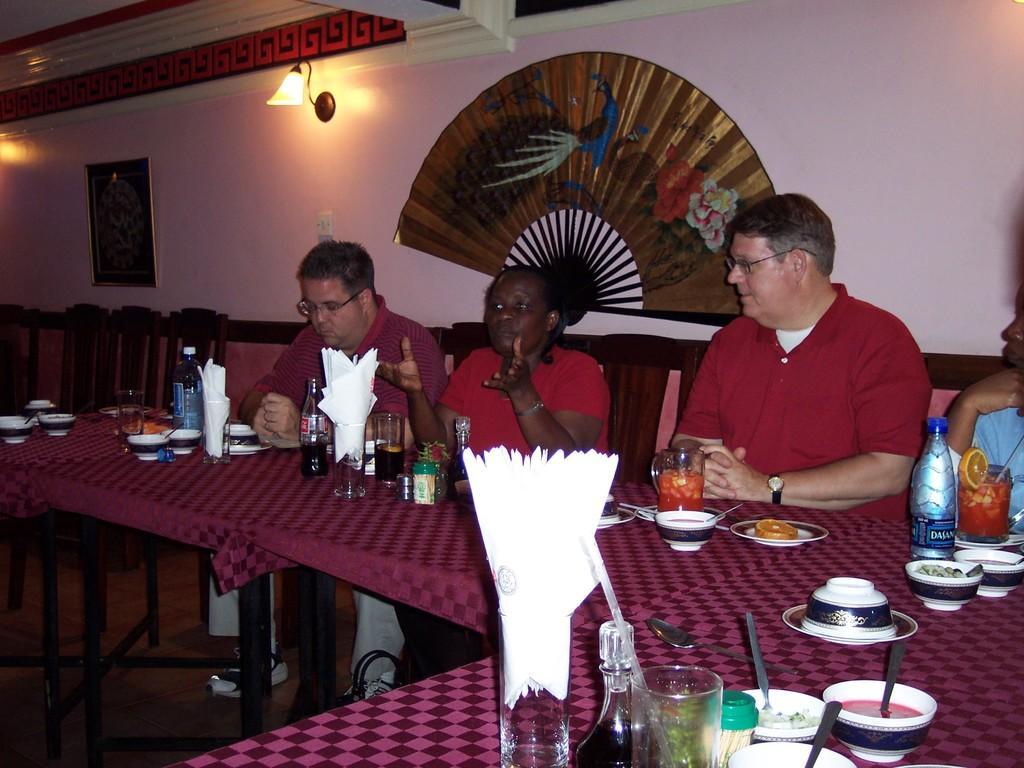How would you summarize this image in a sentence or two? Here in this picture we can see a group of people sitting on chairs with table in front of them with glasses, bottles, bowls and plates of food and tissue papers all present on it over there and the woman in the middle is speaking something and behind them on the wall we can see a portrait and a designed sticker present over there and we can also see lamp posts present over there. 